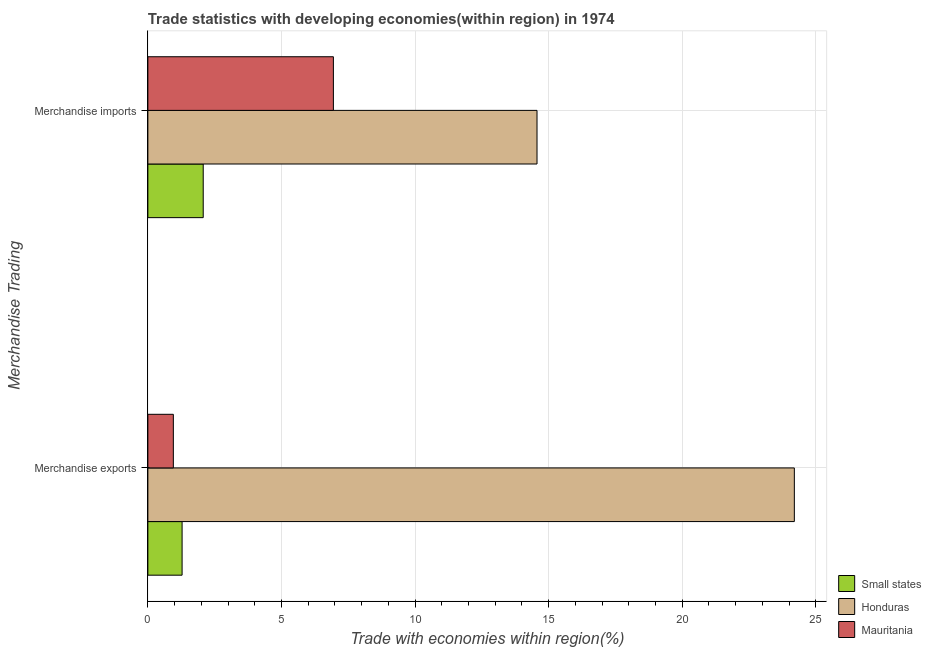How many different coloured bars are there?
Offer a very short reply. 3. Are the number of bars on each tick of the Y-axis equal?
Provide a succinct answer. Yes. How many bars are there on the 1st tick from the top?
Give a very brief answer. 3. How many bars are there on the 2nd tick from the bottom?
Give a very brief answer. 3. What is the merchandise imports in Mauritania?
Ensure brevity in your answer.  6.94. Across all countries, what is the maximum merchandise exports?
Offer a terse response. 24.2. Across all countries, what is the minimum merchandise exports?
Your answer should be very brief. 0.95. In which country was the merchandise imports maximum?
Give a very brief answer. Honduras. In which country was the merchandise imports minimum?
Make the answer very short. Small states. What is the total merchandise exports in the graph?
Your response must be concise. 26.43. What is the difference between the merchandise imports in Honduras and that in Mauritania?
Offer a terse response. 7.62. What is the difference between the merchandise imports in Honduras and the merchandise exports in Small states?
Offer a terse response. 13.29. What is the average merchandise exports per country?
Ensure brevity in your answer.  8.81. What is the difference between the merchandise imports and merchandise exports in Small states?
Make the answer very short. 0.79. In how many countries, is the merchandise exports greater than 18 %?
Provide a short and direct response. 1. What is the ratio of the merchandise imports in Mauritania to that in Small states?
Make the answer very short. 3.35. In how many countries, is the merchandise exports greater than the average merchandise exports taken over all countries?
Your response must be concise. 1. What does the 2nd bar from the top in Merchandise exports represents?
Ensure brevity in your answer.  Honduras. What does the 3rd bar from the bottom in Merchandise exports represents?
Provide a succinct answer. Mauritania. How many bars are there?
Give a very brief answer. 6. How many countries are there in the graph?
Ensure brevity in your answer.  3. Does the graph contain grids?
Keep it short and to the point. Yes. Where does the legend appear in the graph?
Keep it short and to the point. Bottom right. How many legend labels are there?
Provide a succinct answer. 3. How are the legend labels stacked?
Make the answer very short. Vertical. What is the title of the graph?
Your response must be concise. Trade statistics with developing economies(within region) in 1974. What is the label or title of the X-axis?
Offer a very short reply. Trade with economies within region(%). What is the label or title of the Y-axis?
Offer a very short reply. Merchandise Trading. What is the Trade with economies within region(%) in Small states in Merchandise exports?
Your answer should be compact. 1.28. What is the Trade with economies within region(%) in Honduras in Merchandise exports?
Make the answer very short. 24.2. What is the Trade with economies within region(%) of Mauritania in Merchandise exports?
Provide a succinct answer. 0.95. What is the Trade with economies within region(%) in Small states in Merchandise imports?
Provide a succinct answer. 2.07. What is the Trade with economies within region(%) in Honduras in Merchandise imports?
Keep it short and to the point. 14.57. What is the Trade with economies within region(%) in Mauritania in Merchandise imports?
Give a very brief answer. 6.94. Across all Merchandise Trading, what is the maximum Trade with economies within region(%) in Small states?
Your answer should be very brief. 2.07. Across all Merchandise Trading, what is the maximum Trade with economies within region(%) in Honduras?
Provide a succinct answer. 24.2. Across all Merchandise Trading, what is the maximum Trade with economies within region(%) in Mauritania?
Offer a very short reply. 6.94. Across all Merchandise Trading, what is the minimum Trade with economies within region(%) in Small states?
Your answer should be compact. 1.28. Across all Merchandise Trading, what is the minimum Trade with economies within region(%) of Honduras?
Offer a terse response. 14.57. Across all Merchandise Trading, what is the minimum Trade with economies within region(%) in Mauritania?
Offer a terse response. 0.95. What is the total Trade with economies within region(%) of Small states in the graph?
Your response must be concise. 3.35. What is the total Trade with economies within region(%) of Honduras in the graph?
Your answer should be very brief. 38.77. What is the total Trade with economies within region(%) of Mauritania in the graph?
Offer a very short reply. 7.9. What is the difference between the Trade with economies within region(%) of Small states in Merchandise exports and that in Merchandise imports?
Provide a short and direct response. -0.79. What is the difference between the Trade with economies within region(%) in Honduras in Merchandise exports and that in Merchandise imports?
Your answer should be compact. 9.63. What is the difference between the Trade with economies within region(%) of Mauritania in Merchandise exports and that in Merchandise imports?
Provide a short and direct response. -5.99. What is the difference between the Trade with economies within region(%) of Small states in Merchandise exports and the Trade with economies within region(%) of Honduras in Merchandise imports?
Make the answer very short. -13.29. What is the difference between the Trade with economies within region(%) of Small states in Merchandise exports and the Trade with economies within region(%) of Mauritania in Merchandise imports?
Offer a terse response. -5.66. What is the difference between the Trade with economies within region(%) in Honduras in Merchandise exports and the Trade with economies within region(%) in Mauritania in Merchandise imports?
Provide a short and direct response. 17.26. What is the average Trade with economies within region(%) of Small states per Merchandise Trading?
Provide a succinct answer. 1.68. What is the average Trade with economies within region(%) in Honduras per Merchandise Trading?
Give a very brief answer. 19.38. What is the average Trade with economies within region(%) in Mauritania per Merchandise Trading?
Keep it short and to the point. 3.95. What is the difference between the Trade with economies within region(%) of Small states and Trade with economies within region(%) of Honduras in Merchandise exports?
Ensure brevity in your answer.  -22.92. What is the difference between the Trade with economies within region(%) in Small states and Trade with economies within region(%) in Mauritania in Merchandise exports?
Ensure brevity in your answer.  0.33. What is the difference between the Trade with economies within region(%) in Honduras and Trade with economies within region(%) in Mauritania in Merchandise exports?
Provide a succinct answer. 23.25. What is the difference between the Trade with economies within region(%) in Small states and Trade with economies within region(%) in Honduras in Merchandise imports?
Your answer should be compact. -12.5. What is the difference between the Trade with economies within region(%) in Small states and Trade with economies within region(%) in Mauritania in Merchandise imports?
Make the answer very short. -4.87. What is the difference between the Trade with economies within region(%) in Honduras and Trade with economies within region(%) in Mauritania in Merchandise imports?
Your answer should be very brief. 7.62. What is the ratio of the Trade with economies within region(%) of Small states in Merchandise exports to that in Merchandise imports?
Ensure brevity in your answer.  0.62. What is the ratio of the Trade with economies within region(%) of Honduras in Merchandise exports to that in Merchandise imports?
Keep it short and to the point. 1.66. What is the ratio of the Trade with economies within region(%) in Mauritania in Merchandise exports to that in Merchandise imports?
Give a very brief answer. 0.14. What is the difference between the highest and the second highest Trade with economies within region(%) in Small states?
Your answer should be very brief. 0.79. What is the difference between the highest and the second highest Trade with economies within region(%) of Honduras?
Offer a very short reply. 9.63. What is the difference between the highest and the second highest Trade with economies within region(%) of Mauritania?
Offer a terse response. 5.99. What is the difference between the highest and the lowest Trade with economies within region(%) in Small states?
Make the answer very short. 0.79. What is the difference between the highest and the lowest Trade with economies within region(%) in Honduras?
Your answer should be compact. 9.63. What is the difference between the highest and the lowest Trade with economies within region(%) in Mauritania?
Your answer should be very brief. 5.99. 